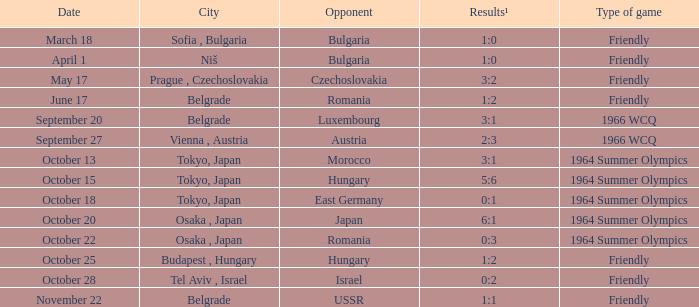What was the opponent on october 28? Israel. 